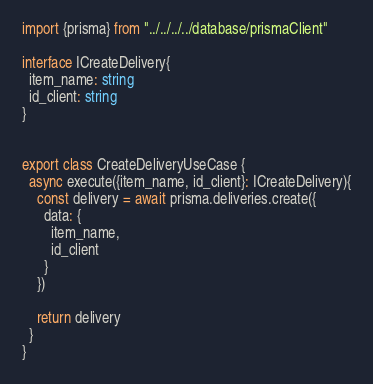Convert code to text. <code><loc_0><loc_0><loc_500><loc_500><_TypeScript_>import {prisma} from "../../../../database/prismaClient"

interface ICreateDelivery{
  item_name: string
  id_client: string
}


export class CreateDeliveryUseCase {
  async execute({item_name, id_client}: ICreateDelivery){
    const delivery = await prisma.deliveries.create({
      data: {
        item_name,
        id_client
      }
    })

    return delivery
  }
}</code> 